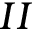Convert formula to latex. <formula><loc_0><loc_0><loc_500><loc_500>I I</formula> 